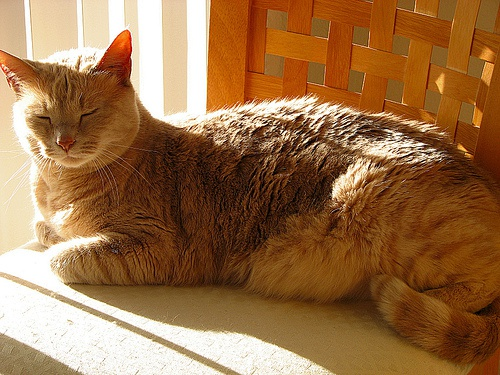Describe the objects in this image and their specific colors. I can see cat in tan, maroon, brown, and black tones and chair in tan, brown, maroon, and red tones in this image. 